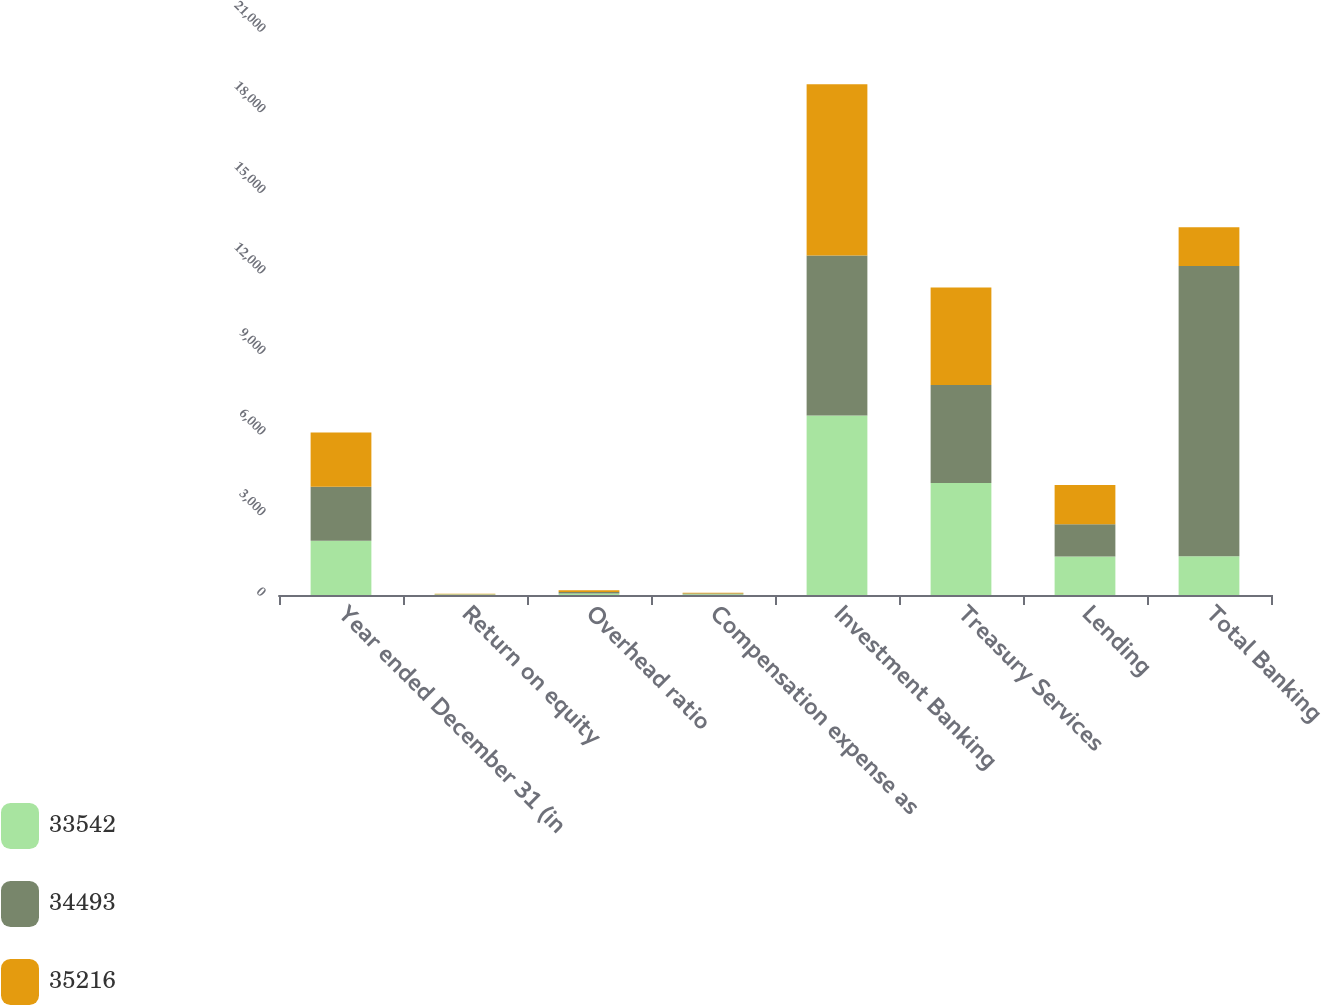<chart> <loc_0><loc_0><loc_500><loc_500><stacked_bar_chart><ecel><fcel>Year ended December 31 (in<fcel>Return on equity<fcel>Overhead ratio<fcel>Compensation expense as<fcel>Investment Banking<fcel>Treasury Services<fcel>Lending<fcel>Total Banking<nl><fcel>33542<fcel>2017<fcel>14<fcel>56<fcel>28<fcel>6688<fcel>4172<fcel>1429<fcel>1445<nl><fcel>34493<fcel>2016<fcel>16<fcel>54<fcel>27<fcel>5950<fcel>3643<fcel>1208<fcel>10801<nl><fcel>35216<fcel>2015<fcel>12<fcel>64<fcel>30<fcel>6376<fcel>3631<fcel>1461<fcel>1445<nl></chart> 